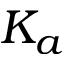<formula> <loc_0><loc_0><loc_500><loc_500>K _ { a }</formula> 